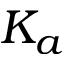<formula> <loc_0><loc_0><loc_500><loc_500>K _ { a }</formula> 